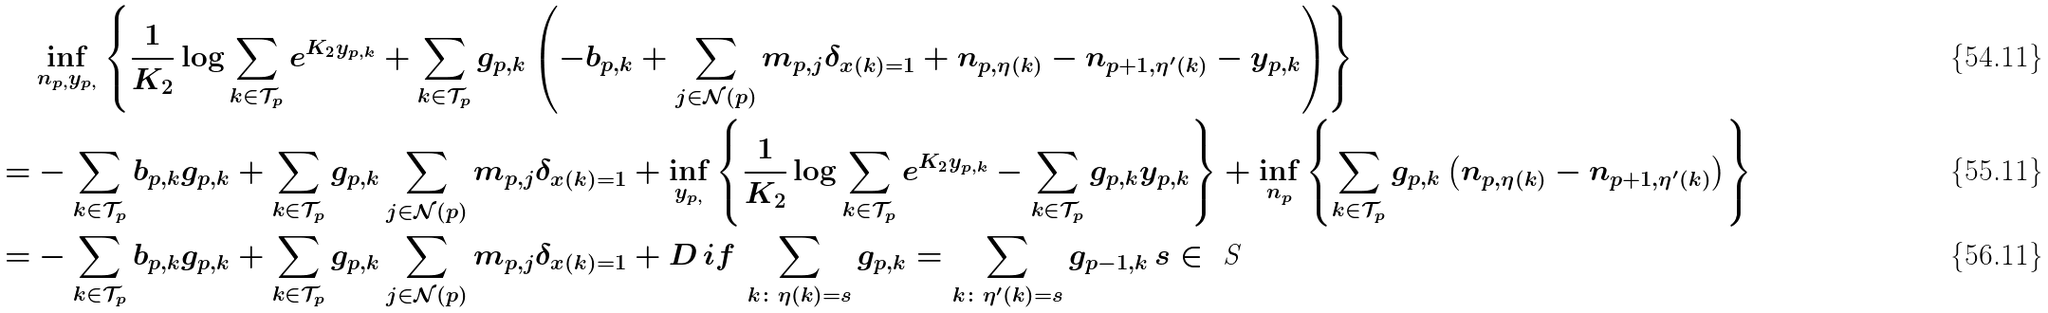<formula> <loc_0><loc_0><loc_500><loc_500>& \inf _ { n _ { p , } y _ { p , } } \left \{ \frac { 1 } { K _ { 2 } } \log \sum _ { k \in \mathcal { T } _ { p } } e ^ { K _ { 2 } y _ { p , k } } + \sum _ { k \in \mathcal { T } _ { p } } g _ { p , k } \left ( - b _ { p , k } + \sum _ { j \in \mathcal { N } ( p ) } m _ { p , j } \delta _ { x ( k ) = 1 } + n _ { p , \eta ( k ) } - n _ { p + 1 , \eta ^ { \prime } ( k ) } - y _ { p , k } \right ) \right \} \\ = & - \sum _ { k \in \mathcal { T } _ { p } } b _ { p , k } g _ { p , k } + \sum _ { k \in \mathcal { T } _ { p } } g _ { p , k } \sum _ { j \in \mathcal { N } ( p ) } m _ { p , j } \delta _ { x ( k ) = 1 } + \inf _ { y _ { p , } } \left \{ \frac { 1 } { K _ { 2 } } \log \sum _ { k \in \mathcal { T } _ { p } } e ^ { K _ { 2 } y _ { p , k } } - \sum _ { k \in \mathcal { T } _ { p } } g _ { p , k } y _ { p , k } \right \} + \inf _ { n _ { p } } \left \{ \sum _ { k \in \mathcal { T } _ { p } } g _ { p , k } \left ( n _ { p , \eta ( k ) } - n _ { p + 1 , \eta ^ { \prime } ( k ) } \right ) \right \} \\ = & - \sum _ { k \in \mathcal { T } _ { p } } b _ { p , k } g _ { p , k } + \sum _ { k \in \mathcal { T } _ { p } } g _ { p , k } \sum _ { j \in \mathcal { N } ( p ) } m _ { p , j } \delta _ { x ( k ) = 1 } + D \, i f \, \sum _ { k \colon \eta ( k ) = s } g _ { p , k } = \sum _ { k \colon \eta ^ { \prime } ( k ) = s } g _ { p - 1 , k } \, s \in \emph { S }</formula> 